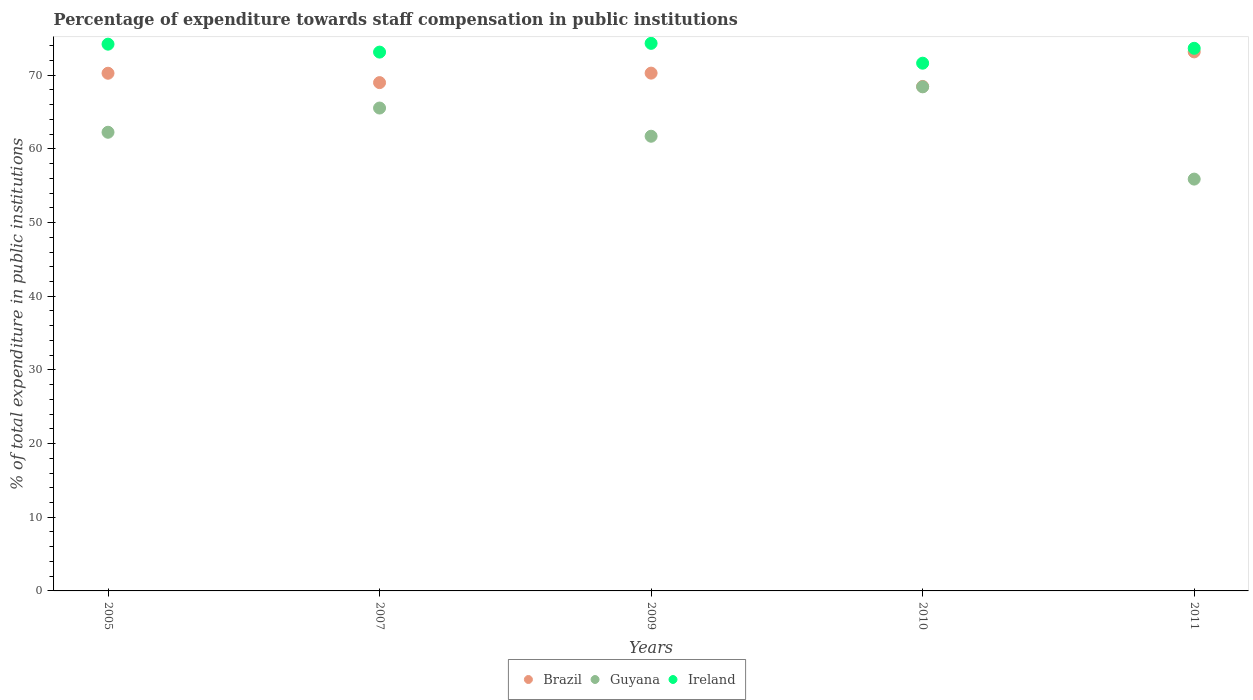How many different coloured dotlines are there?
Ensure brevity in your answer.  3. Is the number of dotlines equal to the number of legend labels?
Provide a short and direct response. Yes. What is the percentage of expenditure towards staff compensation in Brazil in 2010?
Make the answer very short. 68.47. Across all years, what is the maximum percentage of expenditure towards staff compensation in Brazil?
Make the answer very short. 73.17. Across all years, what is the minimum percentage of expenditure towards staff compensation in Ireland?
Provide a succinct answer. 71.63. In which year was the percentage of expenditure towards staff compensation in Guyana maximum?
Offer a terse response. 2010. In which year was the percentage of expenditure towards staff compensation in Brazil minimum?
Give a very brief answer. 2010. What is the total percentage of expenditure towards staff compensation in Brazil in the graph?
Provide a short and direct response. 351.18. What is the difference between the percentage of expenditure towards staff compensation in Brazil in 2007 and that in 2011?
Keep it short and to the point. -4.17. What is the difference between the percentage of expenditure towards staff compensation in Ireland in 2005 and the percentage of expenditure towards staff compensation in Guyana in 2010?
Provide a short and direct response. 5.79. What is the average percentage of expenditure towards staff compensation in Guyana per year?
Your answer should be very brief. 62.77. In the year 2009, what is the difference between the percentage of expenditure towards staff compensation in Brazil and percentage of expenditure towards staff compensation in Guyana?
Offer a very short reply. 8.57. What is the ratio of the percentage of expenditure towards staff compensation in Brazil in 2007 to that in 2011?
Offer a terse response. 0.94. Is the percentage of expenditure towards staff compensation in Brazil in 2005 less than that in 2009?
Your response must be concise. Yes. What is the difference between the highest and the second highest percentage of expenditure towards staff compensation in Ireland?
Make the answer very short. 0.11. What is the difference between the highest and the lowest percentage of expenditure towards staff compensation in Guyana?
Your answer should be compact. 12.53. Is it the case that in every year, the sum of the percentage of expenditure towards staff compensation in Ireland and percentage of expenditure towards staff compensation in Guyana  is greater than the percentage of expenditure towards staff compensation in Brazil?
Provide a succinct answer. Yes. Does the percentage of expenditure towards staff compensation in Ireland monotonically increase over the years?
Provide a succinct answer. No. Is the percentage of expenditure towards staff compensation in Ireland strictly less than the percentage of expenditure towards staff compensation in Brazil over the years?
Make the answer very short. No. How many dotlines are there?
Keep it short and to the point. 3. What is the difference between two consecutive major ticks on the Y-axis?
Your answer should be very brief. 10. What is the title of the graph?
Your response must be concise. Percentage of expenditure towards staff compensation in public institutions. Does "Mexico" appear as one of the legend labels in the graph?
Provide a succinct answer. No. What is the label or title of the X-axis?
Your answer should be compact. Years. What is the label or title of the Y-axis?
Your answer should be very brief. % of total expenditure in public institutions. What is the % of total expenditure in public institutions of Brazil in 2005?
Your response must be concise. 70.27. What is the % of total expenditure in public institutions of Guyana in 2005?
Provide a succinct answer. 62.26. What is the % of total expenditure in public institutions of Ireland in 2005?
Offer a very short reply. 74.21. What is the % of total expenditure in public institutions of Brazil in 2007?
Make the answer very short. 68.99. What is the % of total expenditure in public institutions of Guyana in 2007?
Give a very brief answer. 65.54. What is the % of total expenditure in public institutions of Ireland in 2007?
Provide a short and direct response. 73.13. What is the % of total expenditure in public institutions of Brazil in 2009?
Make the answer very short. 70.28. What is the % of total expenditure in public institutions of Guyana in 2009?
Your answer should be very brief. 61.71. What is the % of total expenditure in public institutions of Ireland in 2009?
Give a very brief answer. 74.32. What is the % of total expenditure in public institutions of Brazil in 2010?
Your response must be concise. 68.47. What is the % of total expenditure in public institutions of Guyana in 2010?
Keep it short and to the point. 68.42. What is the % of total expenditure in public institutions in Ireland in 2010?
Make the answer very short. 71.63. What is the % of total expenditure in public institutions of Brazil in 2011?
Your answer should be compact. 73.17. What is the % of total expenditure in public institutions of Guyana in 2011?
Offer a very short reply. 55.9. What is the % of total expenditure in public institutions of Ireland in 2011?
Your answer should be very brief. 73.65. Across all years, what is the maximum % of total expenditure in public institutions in Brazil?
Give a very brief answer. 73.17. Across all years, what is the maximum % of total expenditure in public institutions in Guyana?
Make the answer very short. 68.42. Across all years, what is the maximum % of total expenditure in public institutions in Ireland?
Offer a very short reply. 74.32. Across all years, what is the minimum % of total expenditure in public institutions of Brazil?
Provide a succinct answer. 68.47. Across all years, what is the minimum % of total expenditure in public institutions of Guyana?
Make the answer very short. 55.9. Across all years, what is the minimum % of total expenditure in public institutions of Ireland?
Your answer should be very brief. 71.63. What is the total % of total expenditure in public institutions of Brazil in the graph?
Your answer should be compact. 351.18. What is the total % of total expenditure in public institutions in Guyana in the graph?
Your answer should be compact. 313.83. What is the total % of total expenditure in public institutions in Ireland in the graph?
Provide a succinct answer. 366.95. What is the difference between the % of total expenditure in public institutions of Brazil in 2005 and that in 2007?
Provide a short and direct response. 1.27. What is the difference between the % of total expenditure in public institutions of Guyana in 2005 and that in 2007?
Offer a terse response. -3.29. What is the difference between the % of total expenditure in public institutions of Ireland in 2005 and that in 2007?
Give a very brief answer. 1.08. What is the difference between the % of total expenditure in public institutions of Brazil in 2005 and that in 2009?
Offer a very short reply. -0.01. What is the difference between the % of total expenditure in public institutions in Guyana in 2005 and that in 2009?
Make the answer very short. 0.54. What is the difference between the % of total expenditure in public institutions in Ireland in 2005 and that in 2009?
Your response must be concise. -0.11. What is the difference between the % of total expenditure in public institutions of Brazil in 2005 and that in 2010?
Provide a short and direct response. 1.8. What is the difference between the % of total expenditure in public institutions of Guyana in 2005 and that in 2010?
Make the answer very short. -6.17. What is the difference between the % of total expenditure in public institutions in Ireland in 2005 and that in 2010?
Offer a terse response. 2.58. What is the difference between the % of total expenditure in public institutions of Brazil in 2005 and that in 2011?
Your answer should be compact. -2.9. What is the difference between the % of total expenditure in public institutions of Guyana in 2005 and that in 2011?
Ensure brevity in your answer.  6.36. What is the difference between the % of total expenditure in public institutions in Ireland in 2005 and that in 2011?
Keep it short and to the point. 0.56. What is the difference between the % of total expenditure in public institutions in Brazil in 2007 and that in 2009?
Offer a terse response. -1.29. What is the difference between the % of total expenditure in public institutions in Guyana in 2007 and that in 2009?
Your answer should be very brief. 3.83. What is the difference between the % of total expenditure in public institutions in Ireland in 2007 and that in 2009?
Your answer should be very brief. -1.19. What is the difference between the % of total expenditure in public institutions in Brazil in 2007 and that in 2010?
Ensure brevity in your answer.  0.52. What is the difference between the % of total expenditure in public institutions of Guyana in 2007 and that in 2010?
Keep it short and to the point. -2.88. What is the difference between the % of total expenditure in public institutions of Ireland in 2007 and that in 2010?
Ensure brevity in your answer.  1.5. What is the difference between the % of total expenditure in public institutions in Brazil in 2007 and that in 2011?
Your answer should be compact. -4.17. What is the difference between the % of total expenditure in public institutions in Guyana in 2007 and that in 2011?
Your response must be concise. 9.65. What is the difference between the % of total expenditure in public institutions in Ireland in 2007 and that in 2011?
Your answer should be very brief. -0.52. What is the difference between the % of total expenditure in public institutions in Brazil in 2009 and that in 2010?
Your answer should be very brief. 1.81. What is the difference between the % of total expenditure in public institutions in Guyana in 2009 and that in 2010?
Provide a succinct answer. -6.71. What is the difference between the % of total expenditure in public institutions of Ireland in 2009 and that in 2010?
Your response must be concise. 2.69. What is the difference between the % of total expenditure in public institutions of Brazil in 2009 and that in 2011?
Offer a terse response. -2.88. What is the difference between the % of total expenditure in public institutions of Guyana in 2009 and that in 2011?
Make the answer very short. 5.82. What is the difference between the % of total expenditure in public institutions in Ireland in 2009 and that in 2011?
Provide a short and direct response. 0.67. What is the difference between the % of total expenditure in public institutions of Brazil in 2010 and that in 2011?
Offer a very short reply. -4.69. What is the difference between the % of total expenditure in public institutions of Guyana in 2010 and that in 2011?
Your response must be concise. 12.53. What is the difference between the % of total expenditure in public institutions in Ireland in 2010 and that in 2011?
Your answer should be very brief. -2.02. What is the difference between the % of total expenditure in public institutions in Brazil in 2005 and the % of total expenditure in public institutions in Guyana in 2007?
Your answer should be compact. 4.72. What is the difference between the % of total expenditure in public institutions of Brazil in 2005 and the % of total expenditure in public institutions of Ireland in 2007?
Provide a succinct answer. -2.87. What is the difference between the % of total expenditure in public institutions of Guyana in 2005 and the % of total expenditure in public institutions of Ireland in 2007?
Provide a succinct answer. -10.88. What is the difference between the % of total expenditure in public institutions in Brazil in 2005 and the % of total expenditure in public institutions in Guyana in 2009?
Offer a very short reply. 8.55. What is the difference between the % of total expenditure in public institutions of Brazil in 2005 and the % of total expenditure in public institutions of Ireland in 2009?
Your answer should be compact. -4.06. What is the difference between the % of total expenditure in public institutions of Guyana in 2005 and the % of total expenditure in public institutions of Ireland in 2009?
Keep it short and to the point. -12.07. What is the difference between the % of total expenditure in public institutions in Brazil in 2005 and the % of total expenditure in public institutions in Guyana in 2010?
Keep it short and to the point. 1.84. What is the difference between the % of total expenditure in public institutions in Brazil in 2005 and the % of total expenditure in public institutions in Ireland in 2010?
Provide a short and direct response. -1.36. What is the difference between the % of total expenditure in public institutions in Guyana in 2005 and the % of total expenditure in public institutions in Ireland in 2010?
Give a very brief answer. -9.37. What is the difference between the % of total expenditure in public institutions of Brazil in 2005 and the % of total expenditure in public institutions of Guyana in 2011?
Provide a short and direct response. 14.37. What is the difference between the % of total expenditure in public institutions in Brazil in 2005 and the % of total expenditure in public institutions in Ireland in 2011?
Make the answer very short. -3.38. What is the difference between the % of total expenditure in public institutions in Guyana in 2005 and the % of total expenditure in public institutions in Ireland in 2011?
Provide a short and direct response. -11.4. What is the difference between the % of total expenditure in public institutions of Brazil in 2007 and the % of total expenditure in public institutions of Guyana in 2009?
Make the answer very short. 7.28. What is the difference between the % of total expenditure in public institutions in Brazil in 2007 and the % of total expenditure in public institutions in Ireland in 2009?
Offer a terse response. -5.33. What is the difference between the % of total expenditure in public institutions of Guyana in 2007 and the % of total expenditure in public institutions of Ireland in 2009?
Provide a succinct answer. -8.78. What is the difference between the % of total expenditure in public institutions of Brazil in 2007 and the % of total expenditure in public institutions of Ireland in 2010?
Offer a very short reply. -2.64. What is the difference between the % of total expenditure in public institutions of Guyana in 2007 and the % of total expenditure in public institutions of Ireland in 2010?
Provide a succinct answer. -6.09. What is the difference between the % of total expenditure in public institutions of Brazil in 2007 and the % of total expenditure in public institutions of Guyana in 2011?
Your answer should be very brief. 13.1. What is the difference between the % of total expenditure in public institutions in Brazil in 2007 and the % of total expenditure in public institutions in Ireland in 2011?
Your answer should be very brief. -4.66. What is the difference between the % of total expenditure in public institutions of Guyana in 2007 and the % of total expenditure in public institutions of Ireland in 2011?
Provide a succinct answer. -8.11. What is the difference between the % of total expenditure in public institutions in Brazil in 2009 and the % of total expenditure in public institutions in Guyana in 2010?
Give a very brief answer. 1.86. What is the difference between the % of total expenditure in public institutions in Brazil in 2009 and the % of total expenditure in public institutions in Ireland in 2010?
Give a very brief answer. -1.35. What is the difference between the % of total expenditure in public institutions in Guyana in 2009 and the % of total expenditure in public institutions in Ireland in 2010?
Offer a very short reply. -9.92. What is the difference between the % of total expenditure in public institutions in Brazil in 2009 and the % of total expenditure in public institutions in Guyana in 2011?
Offer a very short reply. 14.38. What is the difference between the % of total expenditure in public institutions of Brazil in 2009 and the % of total expenditure in public institutions of Ireland in 2011?
Your response must be concise. -3.37. What is the difference between the % of total expenditure in public institutions of Guyana in 2009 and the % of total expenditure in public institutions of Ireland in 2011?
Give a very brief answer. -11.94. What is the difference between the % of total expenditure in public institutions of Brazil in 2010 and the % of total expenditure in public institutions of Guyana in 2011?
Give a very brief answer. 12.57. What is the difference between the % of total expenditure in public institutions in Brazil in 2010 and the % of total expenditure in public institutions in Ireland in 2011?
Offer a very short reply. -5.18. What is the difference between the % of total expenditure in public institutions in Guyana in 2010 and the % of total expenditure in public institutions in Ireland in 2011?
Your answer should be very brief. -5.23. What is the average % of total expenditure in public institutions in Brazil per year?
Your answer should be very brief. 70.24. What is the average % of total expenditure in public institutions of Guyana per year?
Offer a very short reply. 62.77. What is the average % of total expenditure in public institutions in Ireland per year?
Your answer should be very brief. 73.39. In the year 2005, what is the difference between the % of total expenditure in public institutions of Brazil and % of total expenditure in public institutions of Guyana?
Ensure brevity in your answer.  8.01. In the year 2005, what is the difference between the % of total expenditure in public institutions in Brazil and % of total expenditure in public institutions in Ireland?
Provide a short and direct response. -3.95. In the year 2005, what is the difference between the % of total expenditure in public institutions of Guyana and % of total expenditure in public institutions of Ireland?
Give a very brief answer. -11.96. In the year 2007, what is the difference between the % of total expenditure in public institutions in Brazil and % of total expenditure in public institutions in Guyana?
Make the answer very short. 3.45. In the year 2007, what is the difference between the % of total expenditure in public institutions of Brazil and % of total expenditure in public institutions of Ireland?
Your answer should be compact. -4.14. In the year 2007, what is the difference between the % of total expenditure in public institutions in Guyana and % of total expenditure in public institutions in Ireland?
Make the answer very short. -7.59. In the year 2009, what is the difference between the % of total expenditure in public institutions of Brazil and % of total expenditure in public institutions of Guyana?
Your answer should be compact. 8.57. In the year 2009, what is the difference between the % of total expenditure in public institutions of Brazil and % of total expenditure in public institutions of Ireland?
Provide a short and direct response. -4.04. In the year 2009, what is the difference between the % of total expenditure in public institutions of Guyana and % of total expenditure in public institutions of Ireland?
Give a very brief answer. -12.61. In the year 2010, what is the difference between the % of total expenditure in public institutions of Brazil and % of total expenditure in public institutions of Guyana?
Your answer should be compact. 0.05. In the year 2010, what is the difference between the % of total expenditure in public institutions in Brazil and % of total expenditure in public institutions in Ireland?
Provide a short and direct response. -3.16. In the year 2010, what is the difference between the % of total expenditure in public institutions in Guyana and % of total expenditure in public institutions in Ireland?
Offer a terse response. -3.21. In the year 2011, what is the difference between the % of total expenditure in public institutions of Brazil and % of total expenditure in public institutions of Guyana?
Your answer should be compact. 17.27. In the year 2011, what is the difference between the % of total expenditure in public institutions in Brazil and % of total expenditure in public institutions in Ireland?
Give a very brief answer. -0.49. In the year 2011, what is the difference between the % of total expenditure in public institutions in Guyana and % of total expenditure in public institutions in Ireland?
Your answer should be compact. -17.75. What is the ratio of the % of total expenditure in public institutions in Brazil in 2005 to that in 2007?
Offer a very short reply. 1.02. What is the ratio of the % of total expenditure in public institutions of Guyana in 2005 to that in 2007?
Provide a succinct answer. 0.95. What is the ratio of the % of total expenditure in public institutions of Ireland in 2005 to that in 2007?
Provide a short and direct response. 1.01. What is the ratio of the % of total expenditure in public institutions of Brazil in 2005 to that in 2009?
Ensure brevity in your answer.  1. What is the ratio of the % of total expenditure in public institutions in Guyana in 2005 to that in 2009?
Offer a very short reply. 1.01. What is the ratio of the % of total expenditure in public institutions in Brazil in 2005 to that in 2010?
Provide a succinct answer. 1.03. What is the ratio of the % of total expenditure in public institutions of Guyana in 2005 to that in 2010?
Give a very brief answer. 0.91. What is the ratio of the % of total expenditure in public institutions of Ireland in 2005 to that in 2010?
Your response must be concise. 1.04. What is the ratio of the % of total expenditure in public institutions in Brazil in 2005 to that in 2011?
Your response must be concise. 0.96. What is the ratio of the % of total expenditure in public institutions in Guyana in 2005 to that in 2011?
Your answer should be very brief. 1.11. What is the ratio of the % of total expenditure in public institutions of Ireland in 2005 to that in 2011?
Keep it short and to the point. 1.01. What is the ratio of the % of total expenditure in public institutions of Brazil in 2007 to that in 2009?
Ensure brevity in your answer.  0.98. What is the ratio of the % of total expenditure in public institutions in Guyana in 2007 to that in 2009?
Make the answer very short. 1.06. What is the ratio of the % of total expenditure in public institutions in Ireland in 2007 to that in 2009?
Provide a short and direct response. 0.98. What is the ratio of the % of total expenditure in public institutions of Brazil in 2007 to that in 2010?
Your answer should be very brief. 1.01. What is the ratio of the % of total expenditure in public institutions of Guyana in 2007 to that in 2010?
Provide a short and direct response. 0.96. What is the ratio of the % of total expenditure in public institutions of Ireland in 2007 to that in 2010?
Offer a very short reply. 1.02. What is the ratio of the % of total expenditure in public institutions of Brazil in 2007 to that in 2011?
Keep it short and to the point. 0.94. What is the ratio of the % of total expenditure in public institutions in Guyana in 2007 to that in 2011?
Provide a short and direct response. 1.17. What is the ratio of the % of total expenditure in public institutions of Ireland in 2007 to that in 2011?
Your answer should be compact. 0.99. What is the ratio of the % of total expenditure in public institutions of Brazil in 2009 to that in 2010?
Offer a very short reply. 1.03. What is the ratio of the % of total expenditure in public institutions of Guyana in 2009 to that in 2010?
Your answer should be compact. 0.9. What is the ratio of the % of total expenditure in public institutions of Ireland in 2009 to that in 2010?
Offer a terse response. 1.04. What is the ratio of the % of total expenditure in public institutions in Brazil in 2009 to that in 2011?
Provide a short and direct response. 0.96. What is the ratio of the % of total expenditure in public institutions in Guyana in 2009 to that in 2011?
Your response must be concise. 1.1. What is the ratio of the % of total expenditure in public institutions of Ireland in 2009 to that in 2011?
Your answer should be compact. 1.01. What is the ratio of the % of total expenditure in public institutions of Brazil in 2010 to that in 2011?
Give a very brief answer. 0.94. What is the ratio of the % of total expenditure in public institutions in Guyana in 2010 to that in 2011?
Give a very brief answer. 1.22. What is the ratio of the % of total expenditure in public institutions in Ireland in 2010 to that in 2011?
Your answer should be very brief. 0.97. What is the difference between the highest and the second highest % of total expenditure in public institutions in Brazil?
Your response must be concise. 2.88. What is the difference between the highest and the second highest % of total expenditure in public institutions of Guyana?
Ensure brevity in your answer.  2.88. What is the difference between the highest and the second highest % of total expenditure in public institutions in Ireland?
Provide a succinct answer. 0.11. What is the difference between the highest and the lowest % of total expenditure in public institutions of Brazil?
Ensure brevity in your answer.  4.69. What is the difference between the highest and the lowest % of total expenditure in public institutions in Guyana?
Keep it short and to the point. 12.53. What is the difference between the highest and the lowest % of total expenditure in public institutions of Ireland?
Provide a succinct answer. 2.69. 